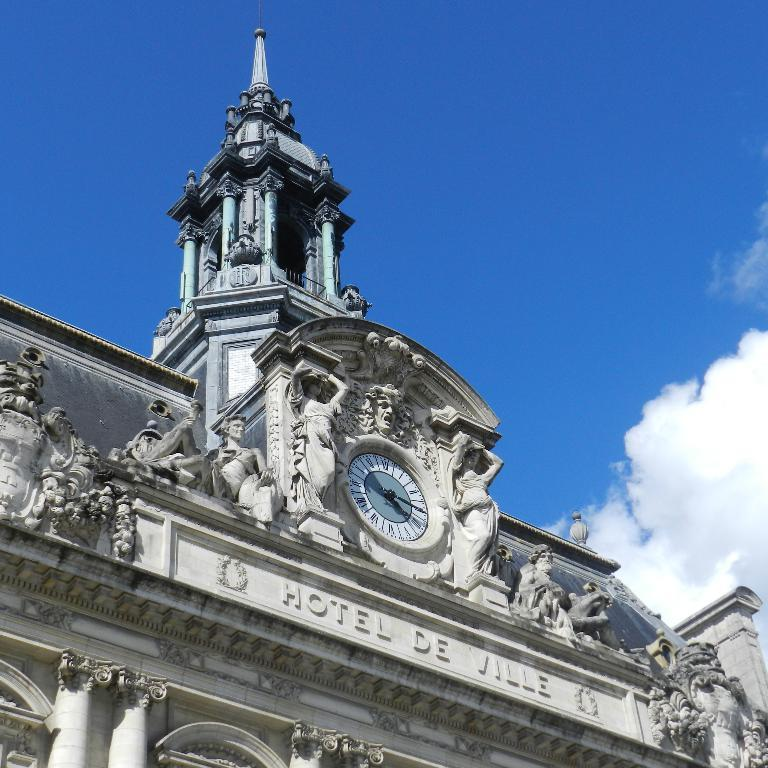<image>
Present a compact description of the photo's key features. Hotel De Ville has elaborate carvings surrounding its sign. 